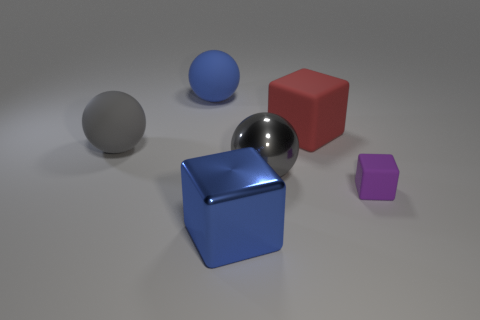Subtract all cyan balls. Subtract all brown cylinders. How many balls are left? 3 Add 4 blue metallic objects. How many objects exist? 10 Add 1 blue shiny things. How many blue shiny things are left? 2 Add 5 big blue rubber things. How many big blue rubber things exist? 6 Subtract 0 yellow cylinders. How many objects are left? 6 Subtract all big blue rubber spheres. Subtract all small purple blocks. How many objects are left? 4 